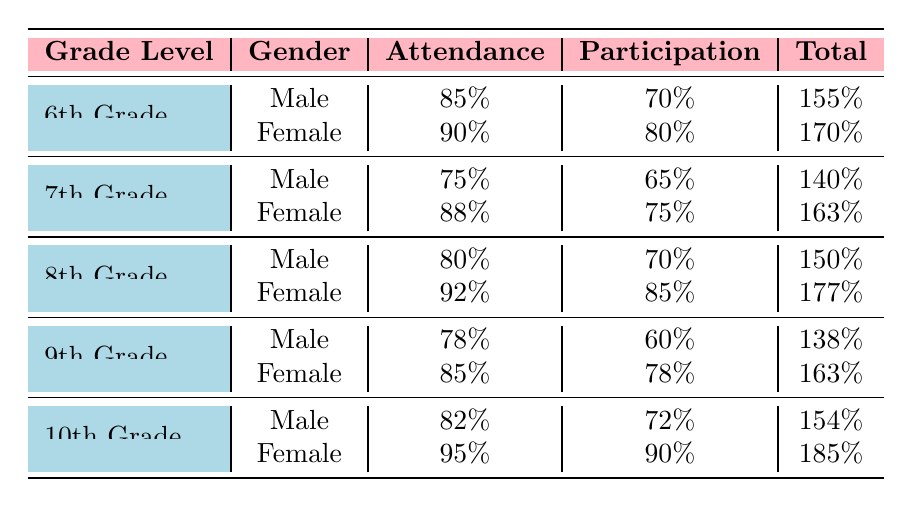What is the attendance percentage of 10th Grade female students? The table indicates that for 10th Grade female students, the attendance percentage is listed directly as 95%.
Answer: 95% Which grade level has the highest participation percentage among male students? By comparing the participation percentages for male students across all grade levels, we see that 8th Grade has the highest participation percentage at 70%.
Answer: 8th Grade What is the difference in attendance percentage between 6th Grade males and 7th Grade females? The attendance percentage for 6th Grade males is 85% and for 7th Grade females is 88%. The difference is calculated by subtracting the two: 88% - 85% = 3%.
Answer: 3% Are the attendance percentages for 9th Grade female students greater than those for 7th Grade males? The attendance percentage for 9th Grade females is 85%, and for 7th Grade males, it is 75%. Since 85% is greater than 75%, the answer is yes.
Answer: Yes Calculate the average participation percentage for all grades among female students. To find the average, we add up all the participation percentages for female students: (80 + 75 + 85 + 78 + 90) = 408. Then we divide by the number of female groups, which is 5: 408 / 5 = 81.6%.
Answer: 81.6% 